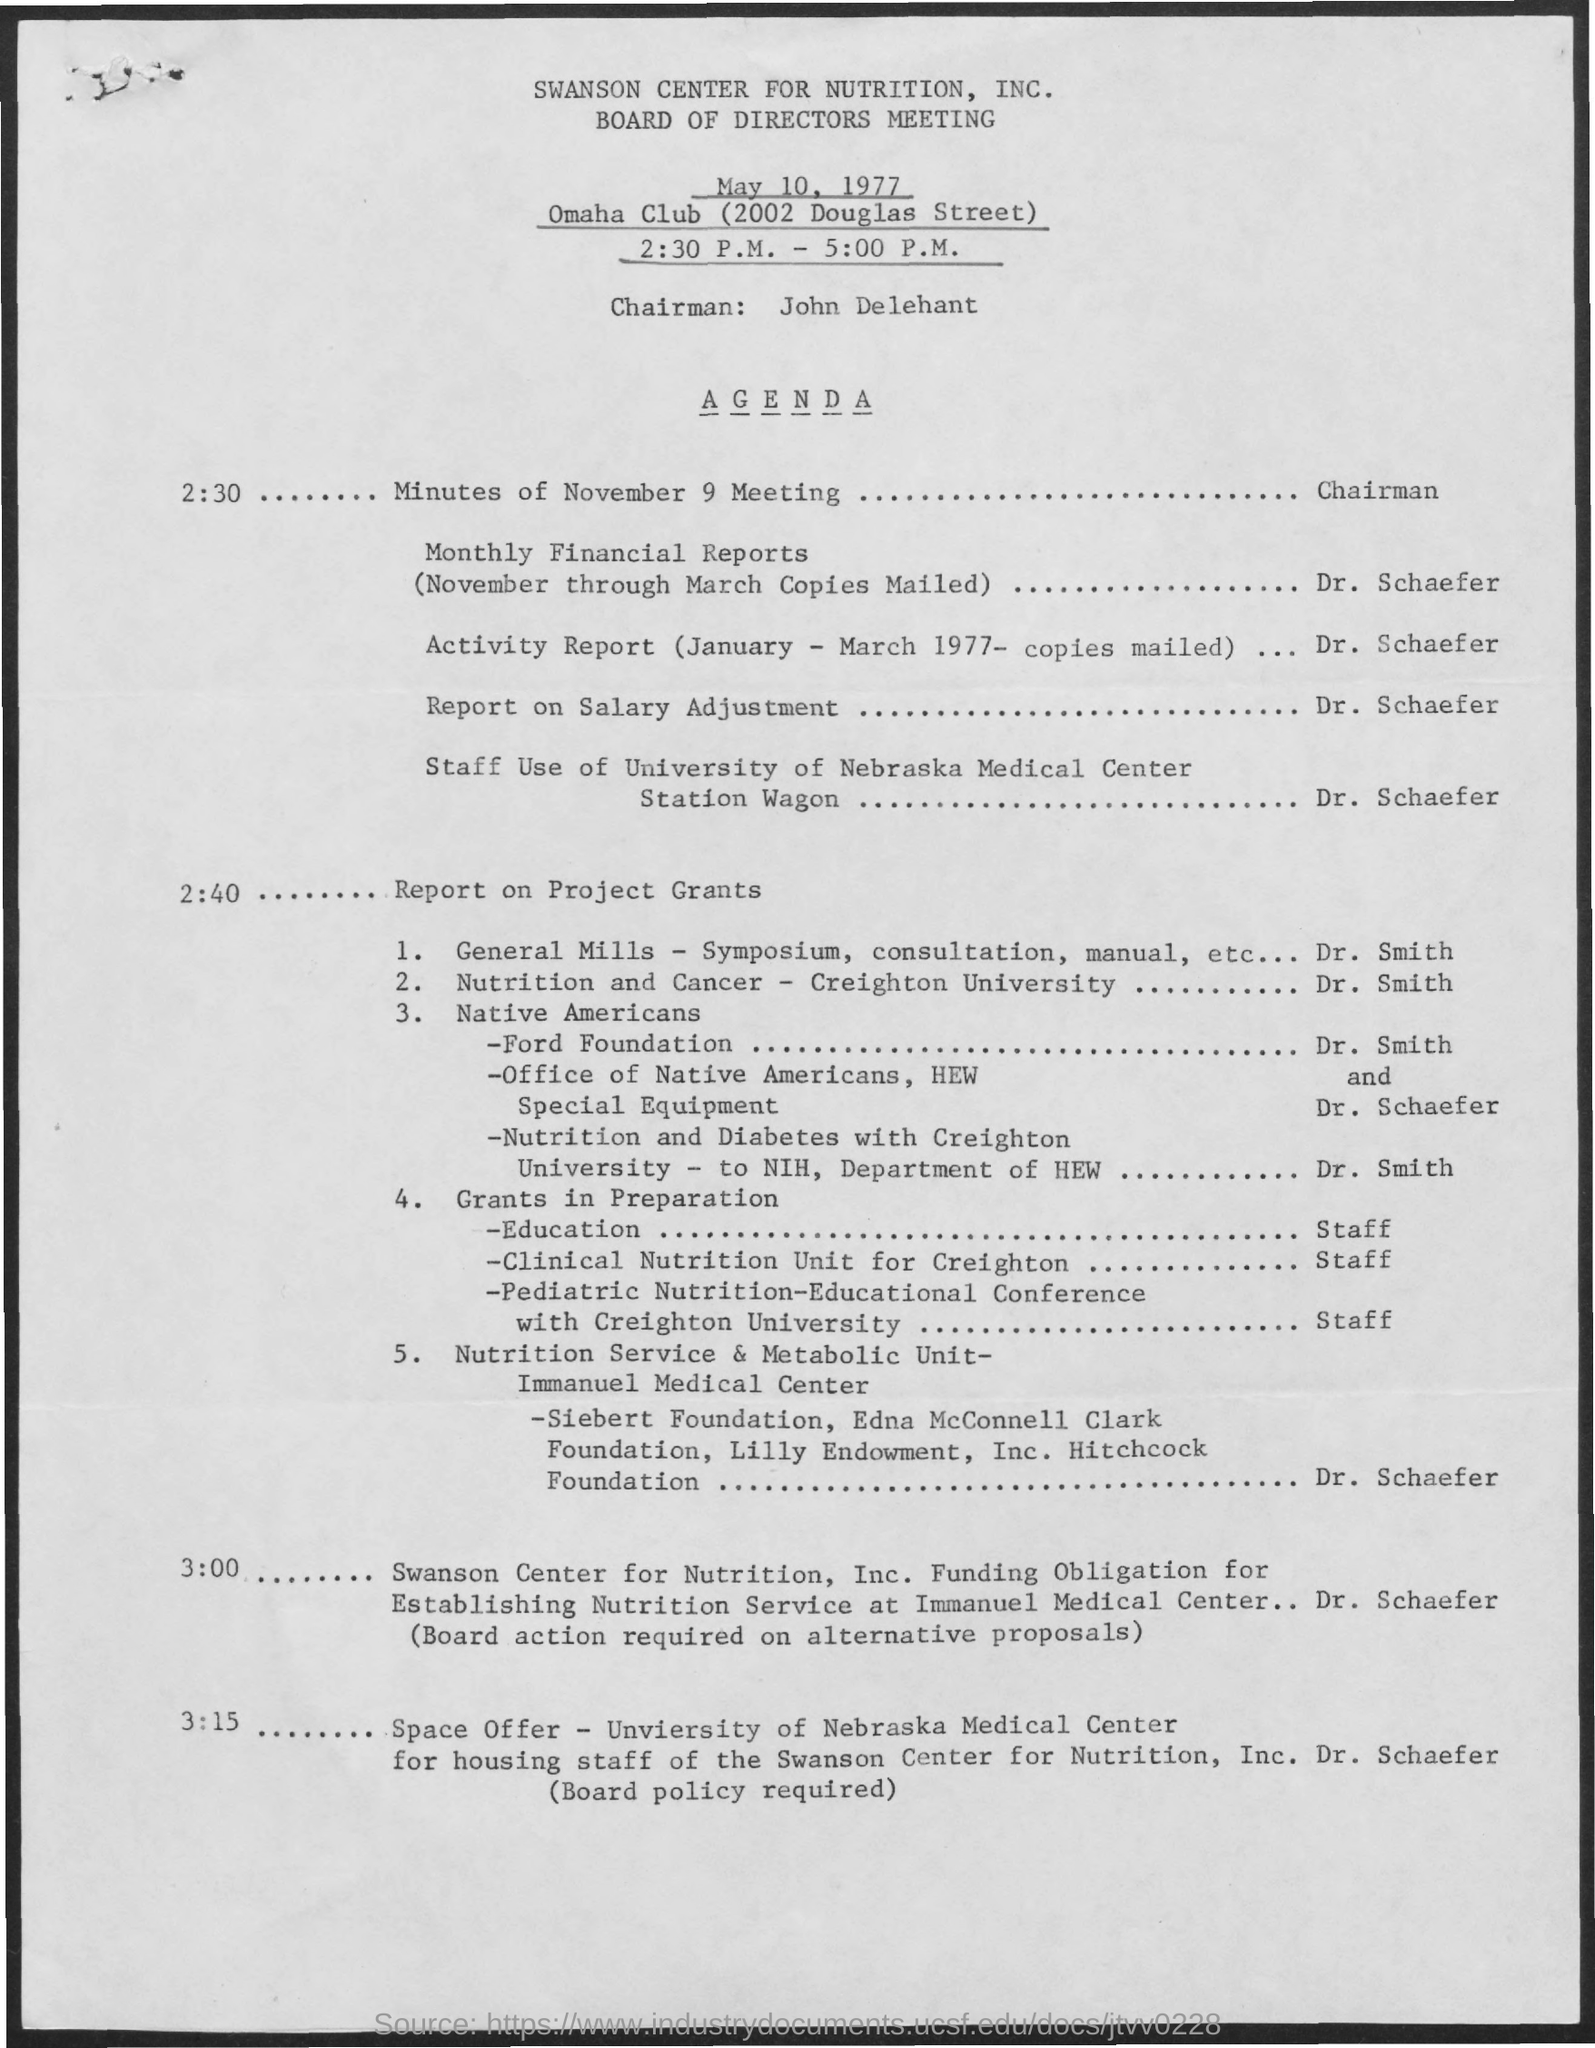Mention a couple of crucial points in this snapshot. The meeting is called the Board of Directors Meeting. The name of the club mentioned is the Omaha Club. The chairman's name is John Delehant. What is the time mentioned? The time mentioned is from 2:30 p.m. to 5:00 p.m. The date mentioned is May 10, 1977. 